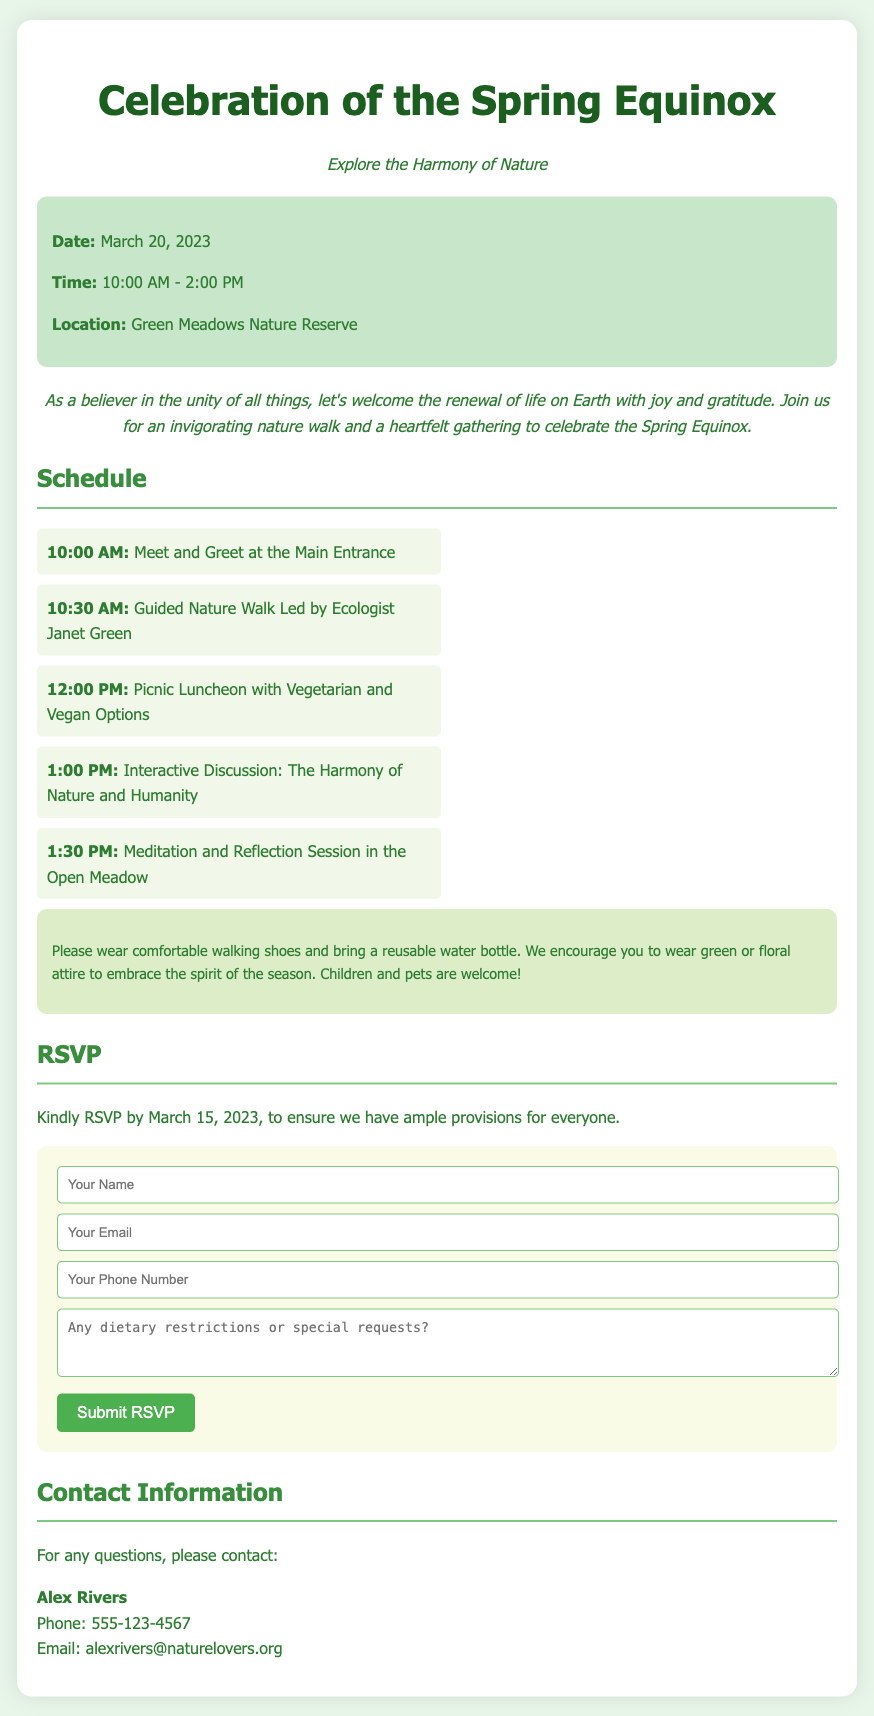What is the date of the celebration? The date is explicitly stated in the document, which is March 20, 2023.
Answer: March 20, 2023 What time does the event start? The time mentioned for the start of the event is 10:00 AM.
Answer: 10:00 AM Where is the gathering taking place? The location is specified in the details section as Green Meadows Nature Reserve.
Answer: Green Meadows Nature Reserve Who is leading the guided nature walk? The document mentions that the guided nature walk is led by Ecologist Janet Green.
Answer: Ecologist Janet Green What should participants wear to the event? The document suggests wearing comfortable walking shoes and encourages wearing green or floral attire.
Answer: Comfortable walking shoes and green or floral attire How many hours will the event last? The event starts at 10:00 AM and ends at 2:00 PM, lasting a total of four hours.
Answer: Four hours What is the deadline for RSVPing? The RSVP deadline mentioned is March 15, 2023.
Answer: March 15, 2023 Are children and pets allowed at the gathering? The additional information explicitly states that children and pets are welcome.
Answer: Yes 